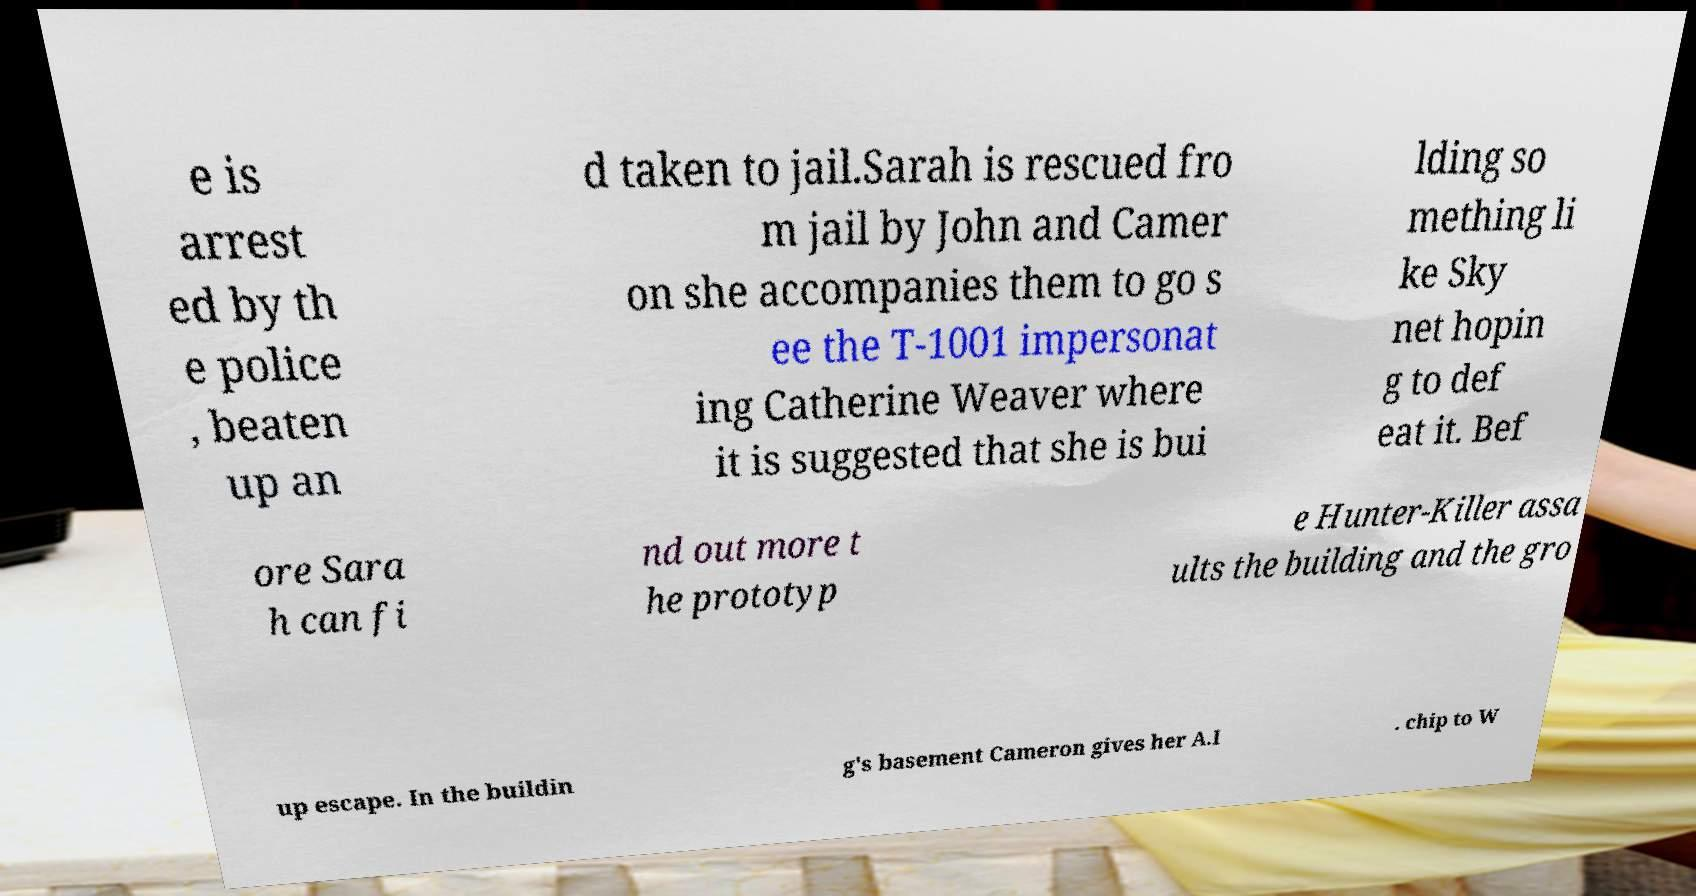For documentation purposes, I need the text within this image transcribed. Could you provide that? e is arrest ed by th e police , beaten up an d taken to jail.Sarah is rescued fro m jail by John and Camer on she accompanies them to go s ee the T-1001 impersonat ing Catherine Weaver where it is suggested that she is bui lding so mething li ke Sky net hopin g to def eat it. Bef ore Sara h can fi nd out more t he prototyp e Hunter-Killer assa ults the building and the gro up escape. In the buildin g's basement Cameron gives her A.I . chip to W 